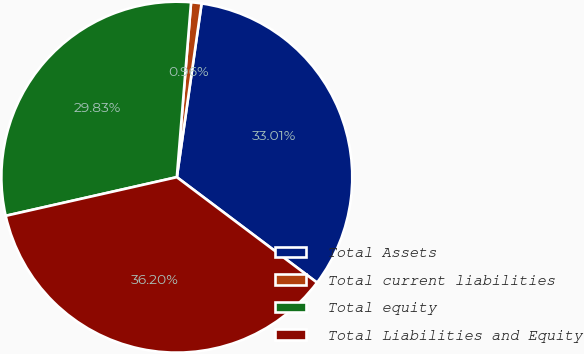<chart> <loc_0><loc_0><loc_500><loc_500><pie_chart><fcel>Total Assets<fcel>Total current liabilities<fcel>Total equity<fcel>Total Liabilities and Equity<nl><fcel>33.01%<fcel>0.96%<fcel>29.83%<fcel>36.2%<nl></chart> 